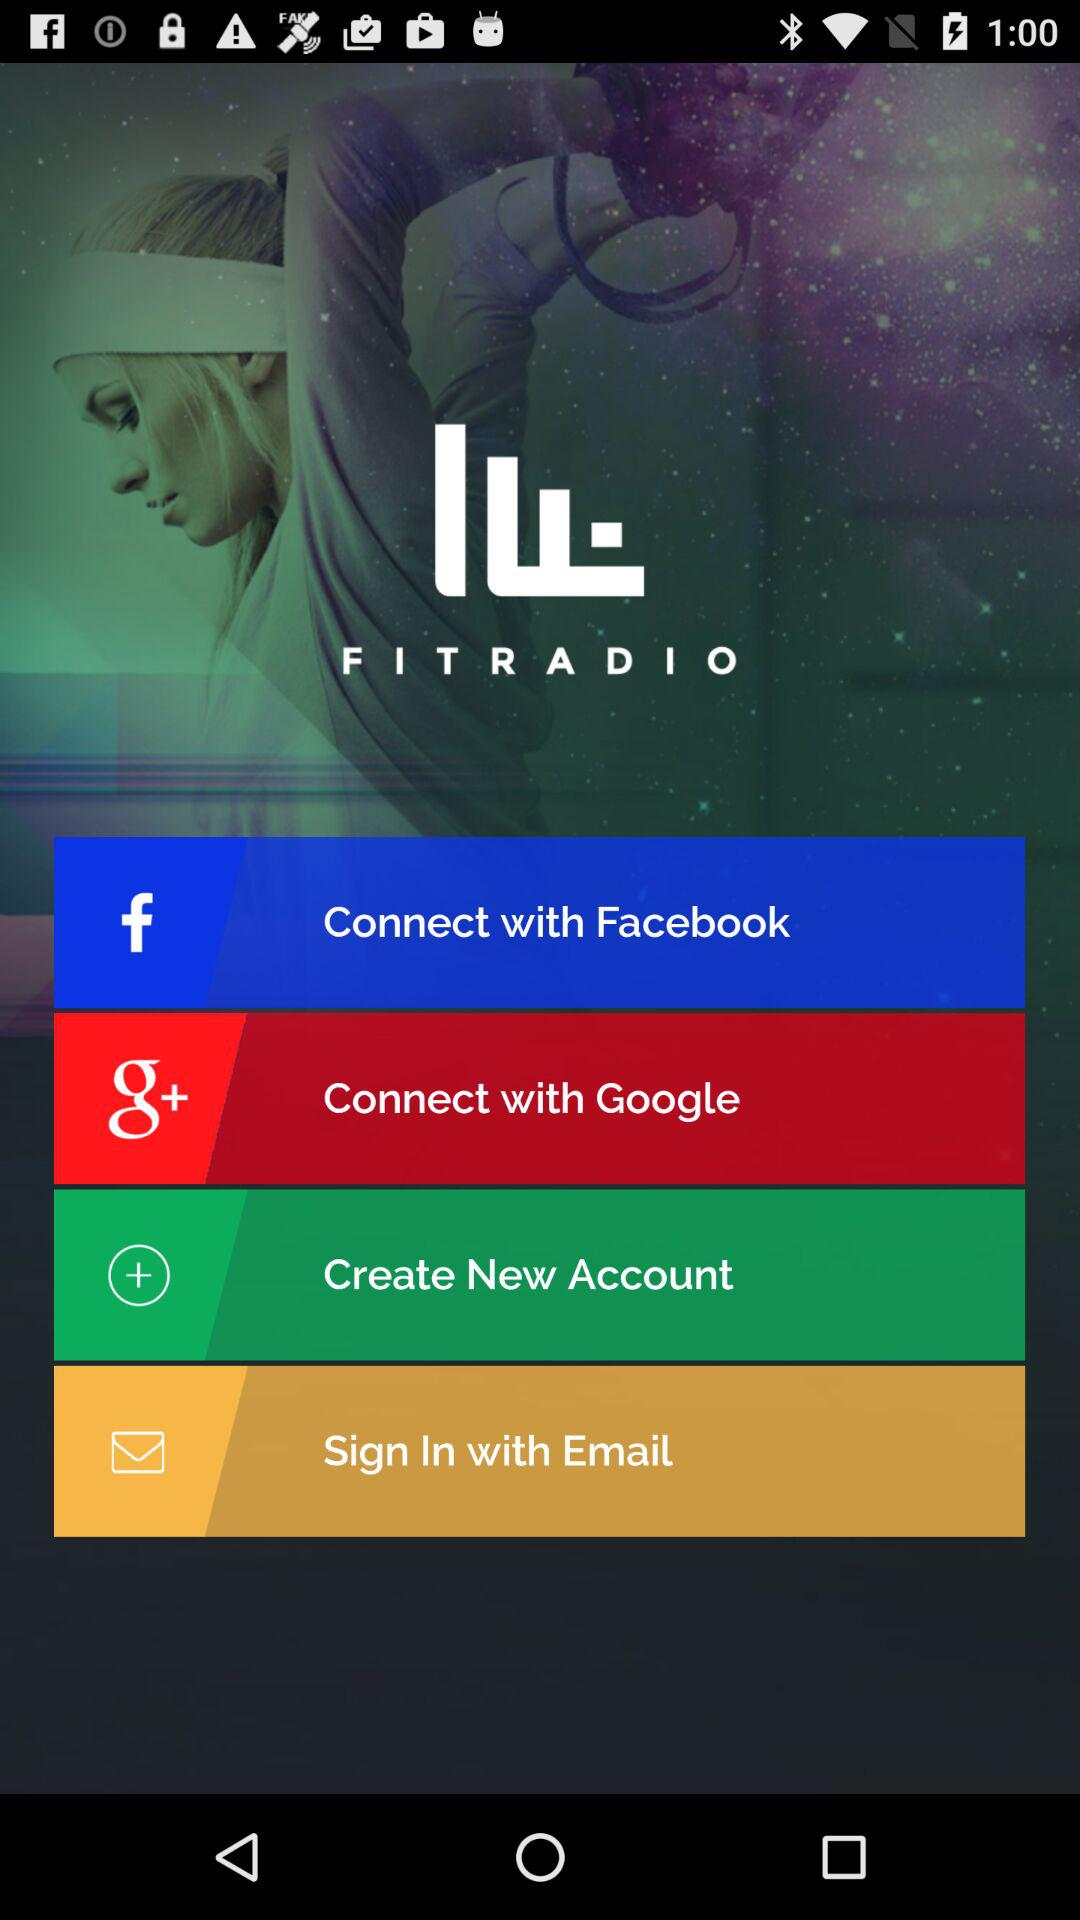What is the application name? The application name is "FITRADIO". 